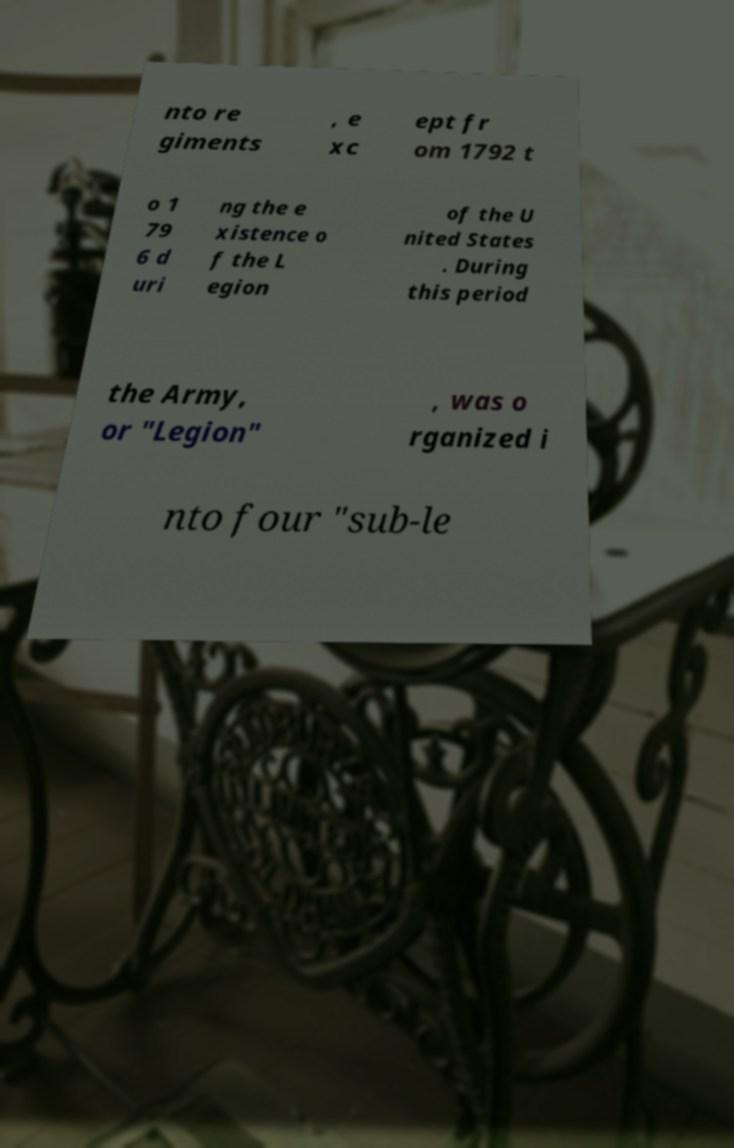Could you extract and type out the text from this image? nto re giments , e xc ept fr om 1792 t o 1 79 6 d uri ng the e xistence o f the L egion of the U nited States . During this period the Army, or "Legion" , was o rganized i nto four "sub-le 